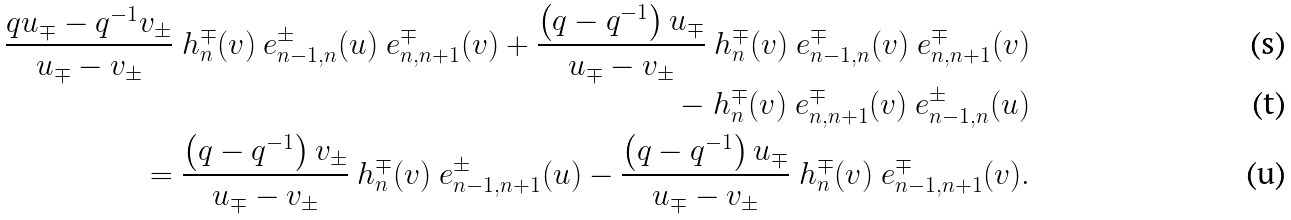Convert formula to latex. <formula><loc_0><loc_0><loc_500><loc_500>\frac { q u _ { \mp } - q ^ { - 1 } v _ { \pm } } { u _ { \mp } - v _ { \pm } } \ h ^ { \mp } _ { n } ( v ) \ e _ { n - 1 , n } ^ { \pm } ( u ) \ e _ { n , n + 1 } ^ { \mp } ( v ) + \frac { \left ( q - q ^ { - 1 } \right ) u _ { \mp } } { u _ { \mp } - v _ { \pm } } \ h ^ { \mp } _ { n } ( v ) \ e _ { n - 1 , n } ^ { \mp } ( v ) \ e _ { n , n + 1 } ^ { \mp } ( v ) \\ \quad - \ h ^ { \mp } _ { n } ( v ) \ e _ { n , n + 1 } ^ { \mp } ( v ) \ e _ { n - 1 , n } ^ { \pm } ( u ) \\ { } = \frac { \left ( q - q ^ { - 1 } \right ) v _ { \pm } } { u _ { \mp } - v _ { \pm } } \ h ^ { \mp } _ { n } ( v ) \ e _ { n - 1 , n + 1 } ^ { \pm } ( u ) - \frac { \left ( q - q ^ { - 1 } \right ) u _ { \mp } } { u _ { \mp } - v _ { \pm } } \ h ^ { \mp } _ { n } ( v ) \ e _ { n - 1 , n + 1 } ^ { \mp } ( v ) .</formula> 